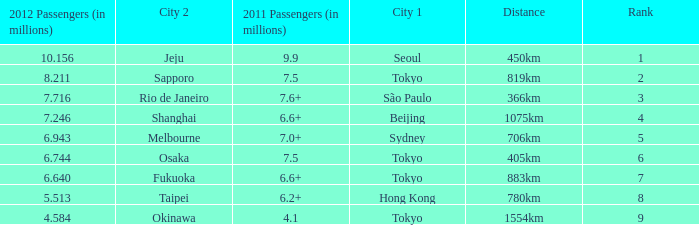In 2011, which city is listed first along the route that had 7.6+ million passengers? São Paulo. Parse the table in full. {'header': ['2012 Passengers (in millions)', 'City 2', '2011 Passengers (in millions)', 'City 1', 'Distance', 'Rank'], 'rows': [['10.156', 'Jeju', '9.9', 'Seoul', '450km', '1'], ['8.211', 'Sapporo', '7.5', 'Tokyo', '819km', '2'], ['7.716', 'Rio de Janeiro', '7.6+', 'São Paulo', '366km', '3'], ['7.246', 'Shanghai', '6.6+', 'Beijing', '1075km', '4'], ['6.943', 'Melbourne', '7.0+', 'Sydney', '706km', '5'], ['6.744', 'Osaka', '7.5', 'Tokyo', '405km', '6'], ['6.640', 'Fukuoka', '6.6+', 'Tokyo', '883km', '7'], ['5.513', 'Taipei', '6.2+', 'Hong Kong', '780km', '8'], ['4.584', 'Okinawa', '4.1', 'Tokyo', '1554km', '9']]} 